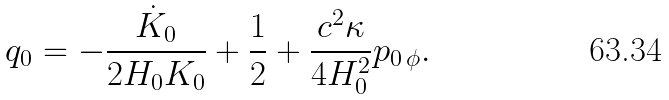Convert formula to latex. <formula><loc_0><loc_0><loc_500><loc_500>q _ { 0 } = - \frac { \dot { K } _ { 0 } } { 2 H _ { 0 } K _ { 0 } } + \frac { 1 } { 2 } + \frac { c ^ { 2 } \kappa } { 4 H _ { 0 } ^ { 2 } } p _ { 0 \, \phi } .</formula> 